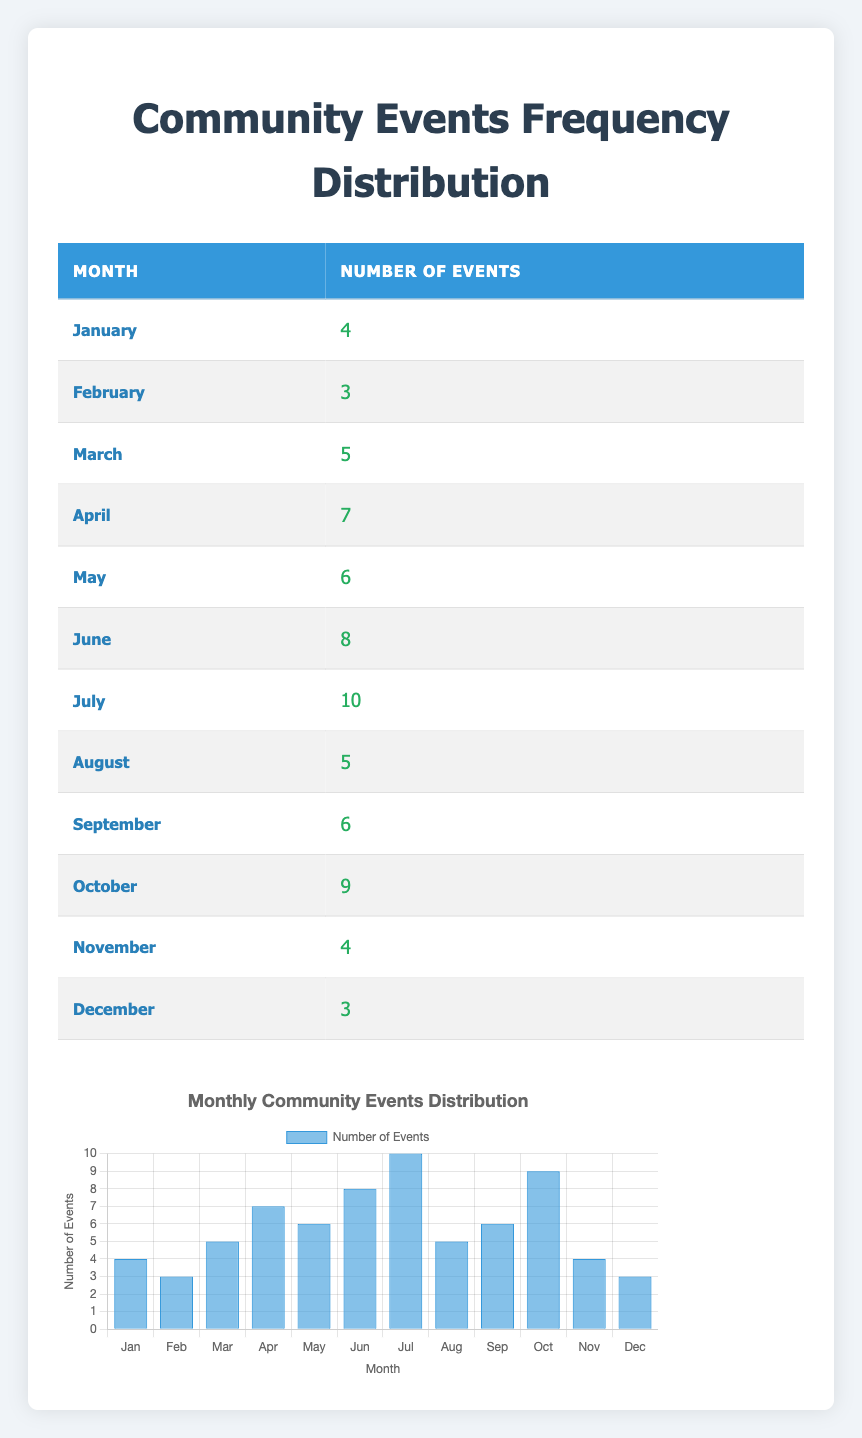What is the month with the highest number of community events? Looking at the table, July has the highest number of events organized, which is 10.
Answer: July How many community events were organized in March? In the table, the number of events organized in March is clearly indicated as 5.
Answer: 5 Which month had fewer events, February or December? February had 3 events while December also had 3 events, so they are equal.
Answer: No, they are equal What is the total number of community events organized from January to March? To find the total, we add the events from January (4), February (3), and March (5): 4 + 3 + 5 = 12.
Answer: 12 What is the average number of community events organized per month? To calculate the average, we first sum the events for all months: 4 + 3 + 5 + 7 + 6 + 8 + 10 + 5 + 6 + 9 + 4 + 3 = 70. There are 12 months, so the average is 70/12 ≈ 5.83.
Answer: Approximately 5.83 Did the organization host more than 6 community events in June? The number of events in June is 8, which is greater than 6.
Answer: Yes How many more events were organized in July than in May? The events in July are 10, and in May they are 6. The difference is 10 - 6 = 4.
Answer: 4 Which two months have the same number of events and what is that number? In the table, both February and December have 3 events each.
Answer: 3 What is the total count of events organized from April to September? From April (7) to September (6), we add: 7 + 6 + 8 + 10 + 5 + 6 = 42.
Answer: 42 